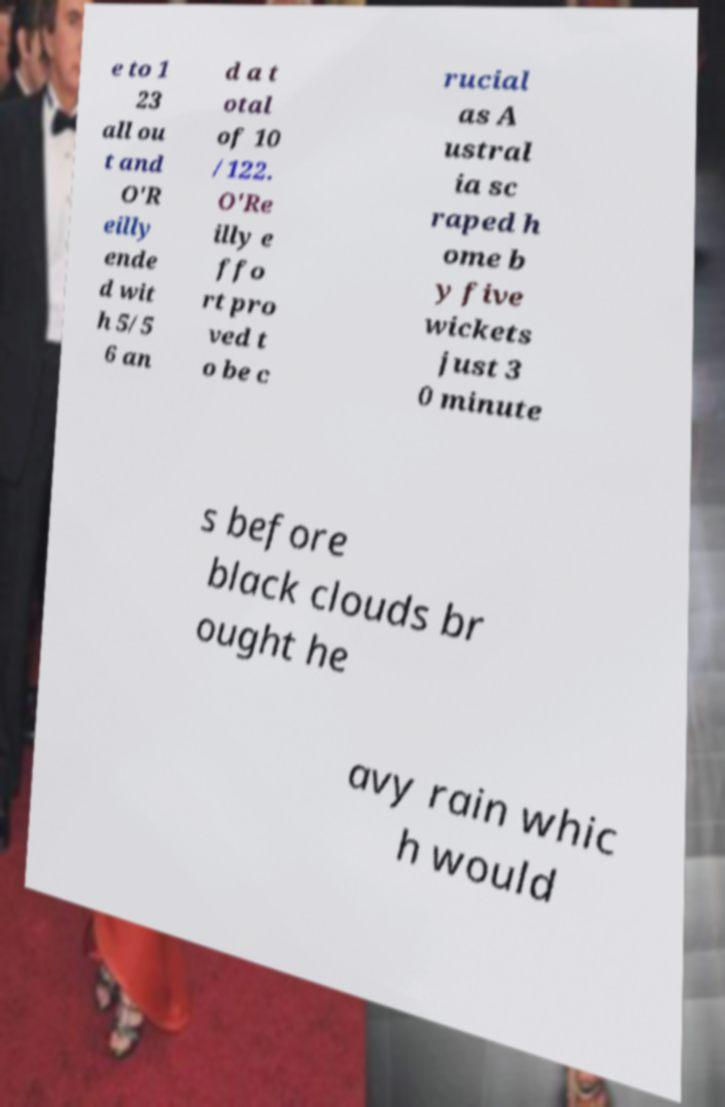Could you extract and type out the text from this image? e to 1 23 all ou t and O'R eilly ende d wit h 5/5 6 an d a t otal of 10 /122. O'Re illy e ffo rt pro ved t o be c rucial as A ustral ia sc raped h ome b y five wickets just 3 0 minute s before black clouds br ought he avy rain whic h would 